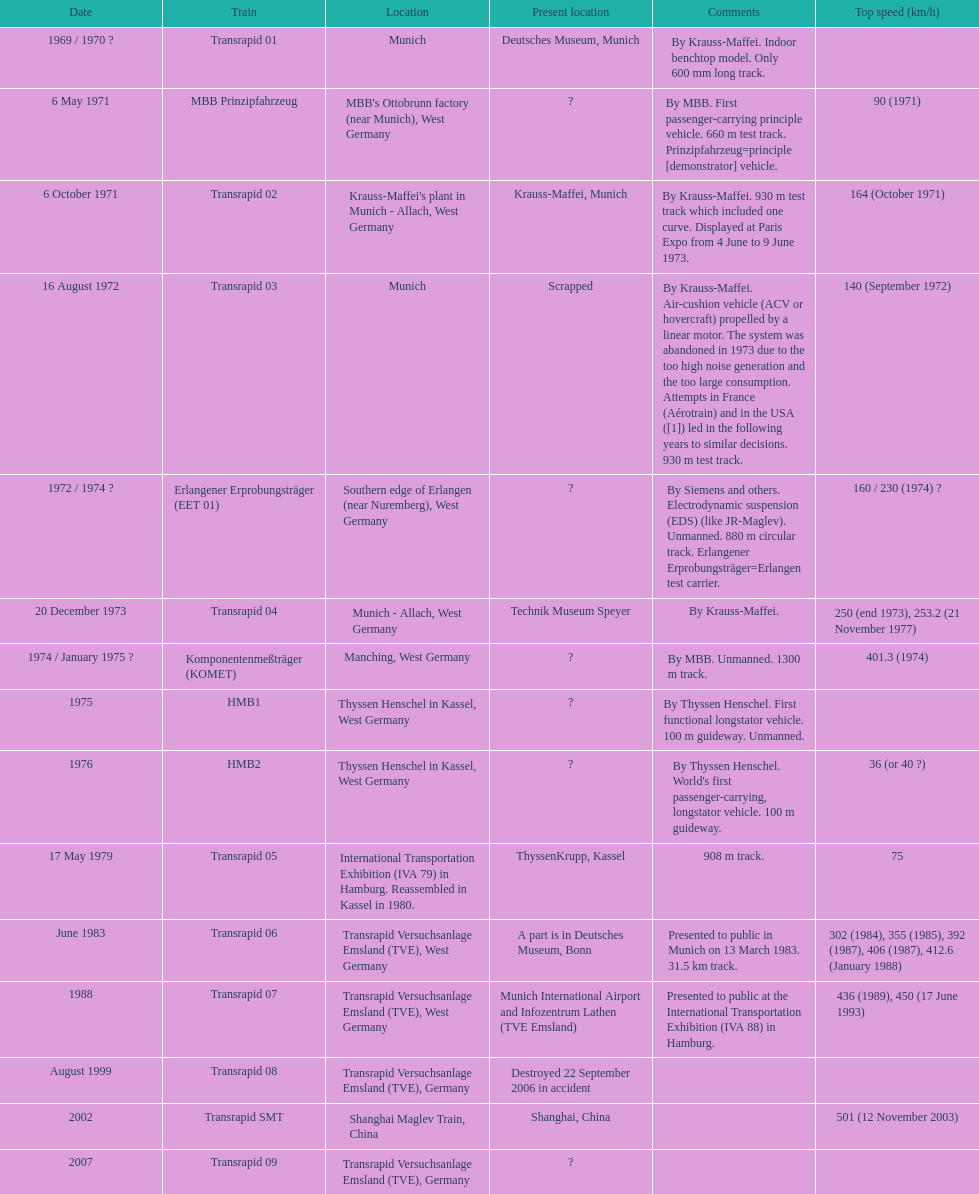What is the quantity of trains that were either scrapped or ruined? 2. 